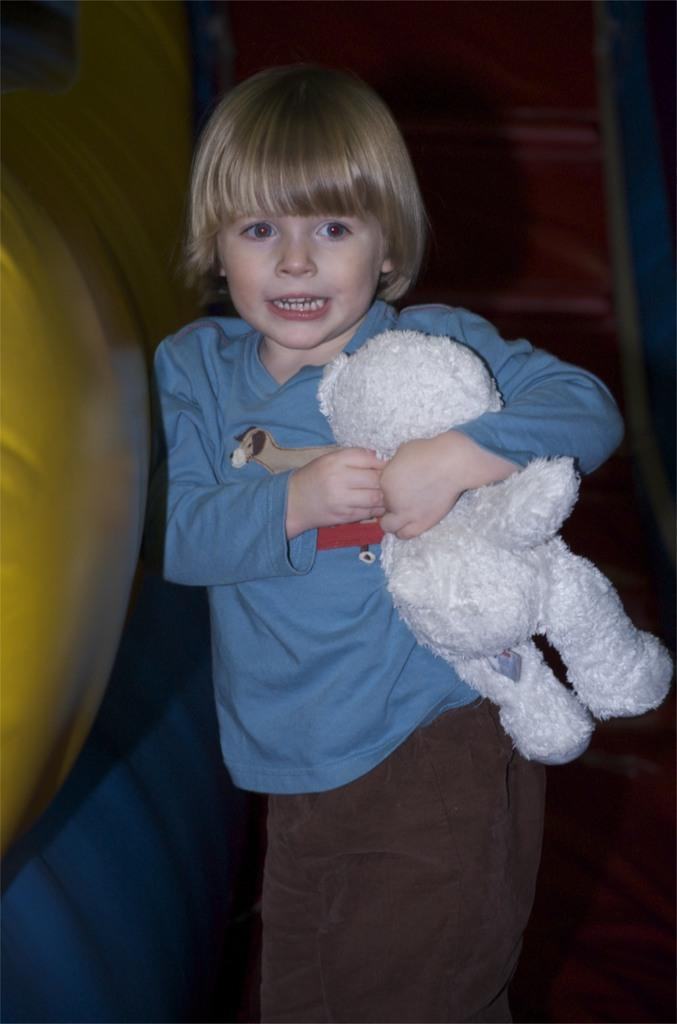What is the person in the image doing? The person is standing in the image. What is the person holding in the image? The person is holding a doll in the image. What color is the person's shirt? The person is wearing a blue shirt. What color are the person's pants? The person is wearing brown pants. What color is the doll? The doll is white in color. What is the color of the background in the image? The background of the image is brown. What type of tin can be seen in the image? There is no tin present in the image. What type of pancake is the person eating in the image? There is no pancake present in the image. 